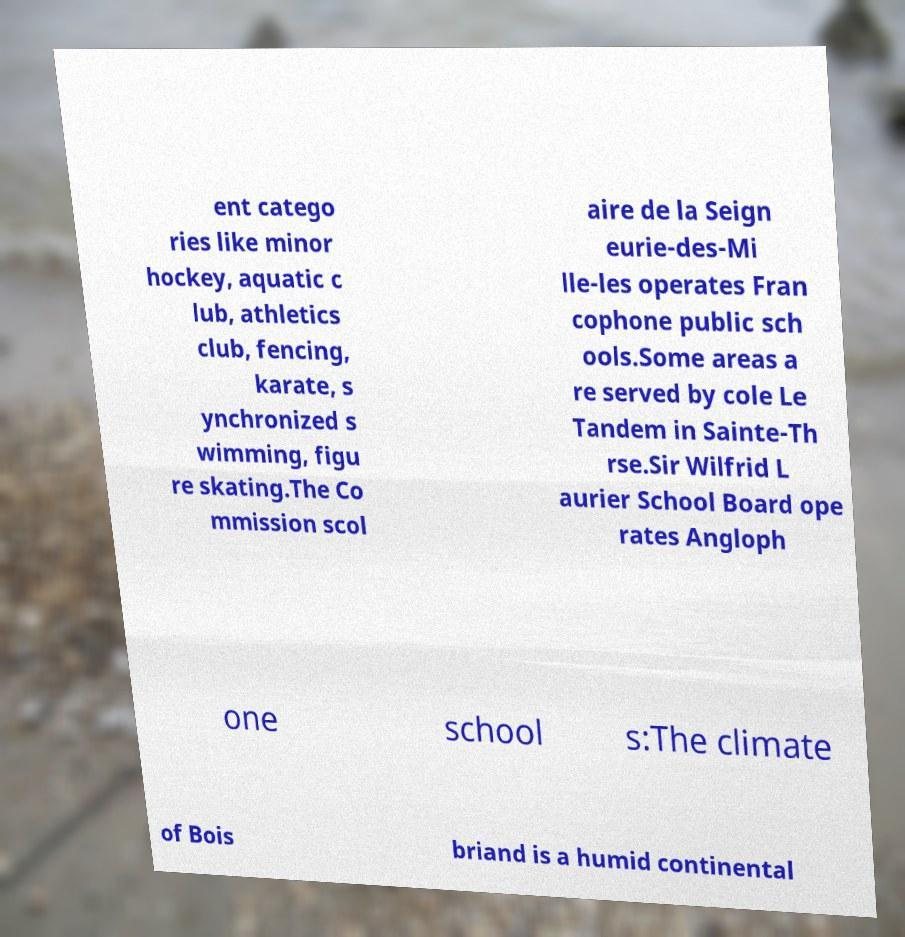Could you extract and type out the text from this image? ent catego ries like minor hockey, aquatic c lub, athletics club, fencing, karate, s ynchronized s wimming, figu re skating.The Co mmission scol aire de la Seign eurie-des-Mi lle-les operates Fran cophone public sch ools.Some areas a re served by cole Le Tandem in Sainte-Th rse.Sir Wilfrid L aurier School Board ope rates Angloph one school s:The climate of Bois briand is a humid continental 